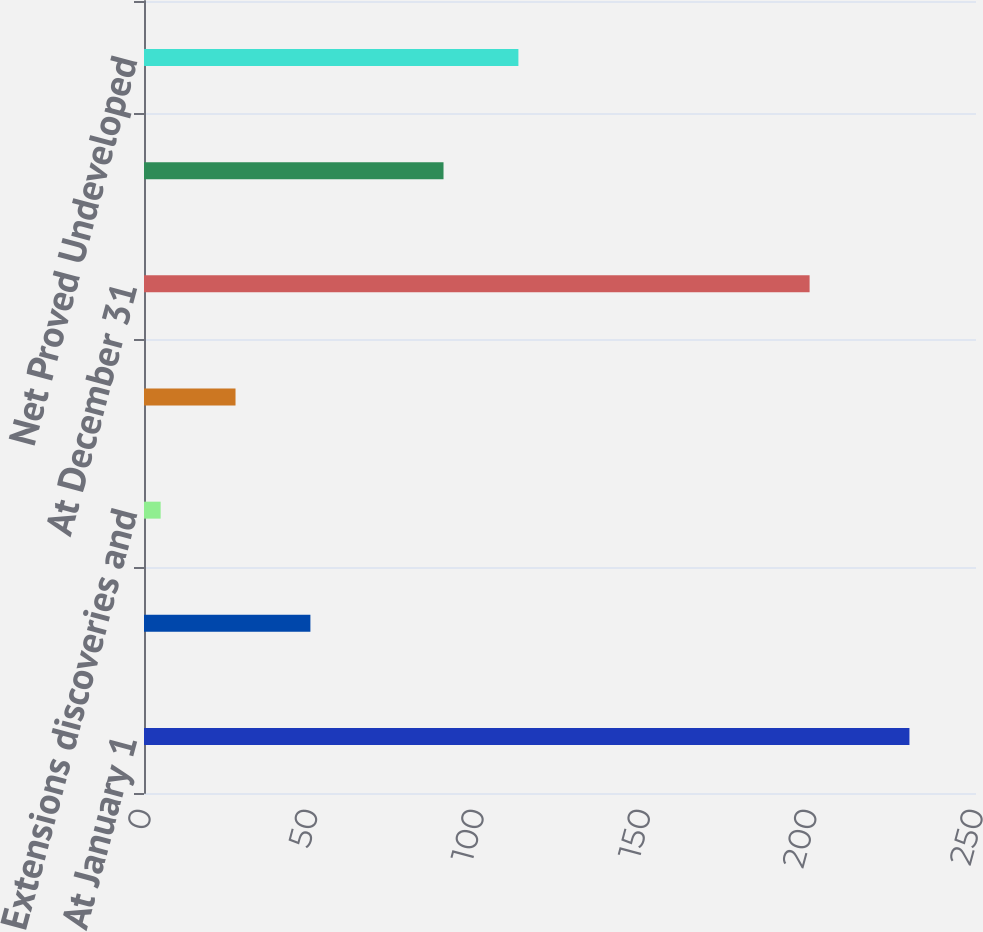<chart> <loc_0><loc_0><loc_500><loc_500><bar_chart><fcel>At January 1<fcel>Revisions of previous<fcel>Extensions discoveries and<fcel>Production<fcel>At December 31<fcel>Net Proved Developed Reserves<fcel>Net Proved Undeveloped<nl><fcel>230<fcel>50<fcel>5<fcel>27.5<fcel>200<fcel>90<fcel>112.5<nl></chart> 